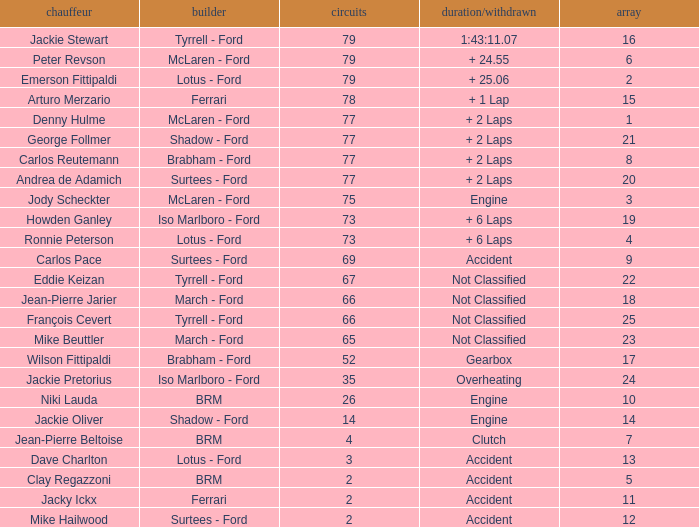How much time is required for less than 35 laps and less than 10 grids? Clutch, Accident. 